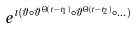<formula> <loc_0><loc_0><loc_500><loc_500>e ^ { \imath ( \vartheta \circ \vartheta ^ { \Theta ( t - t _ { 1 } ) } \circ \vartheta ^ { \Theta ( t - t _ { 2 } ) } \circ \dots ) }</formula> 